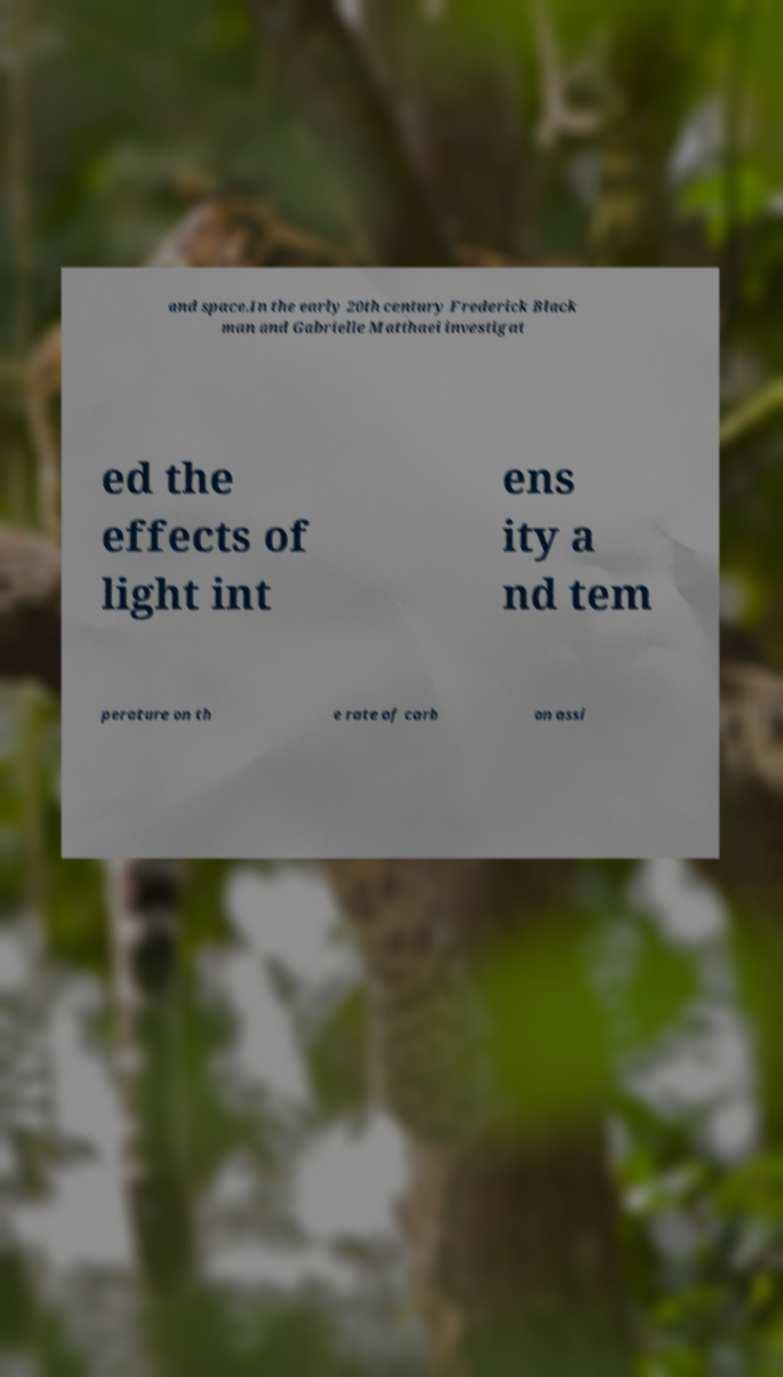Please read and relay the text visible in this image. What does it say? and space.In the early 20th century Frederick Black man and Gabrielle Matthaei investigat ed the effects of light int ens ity a nd tem perature on th e rate of carb on assi 